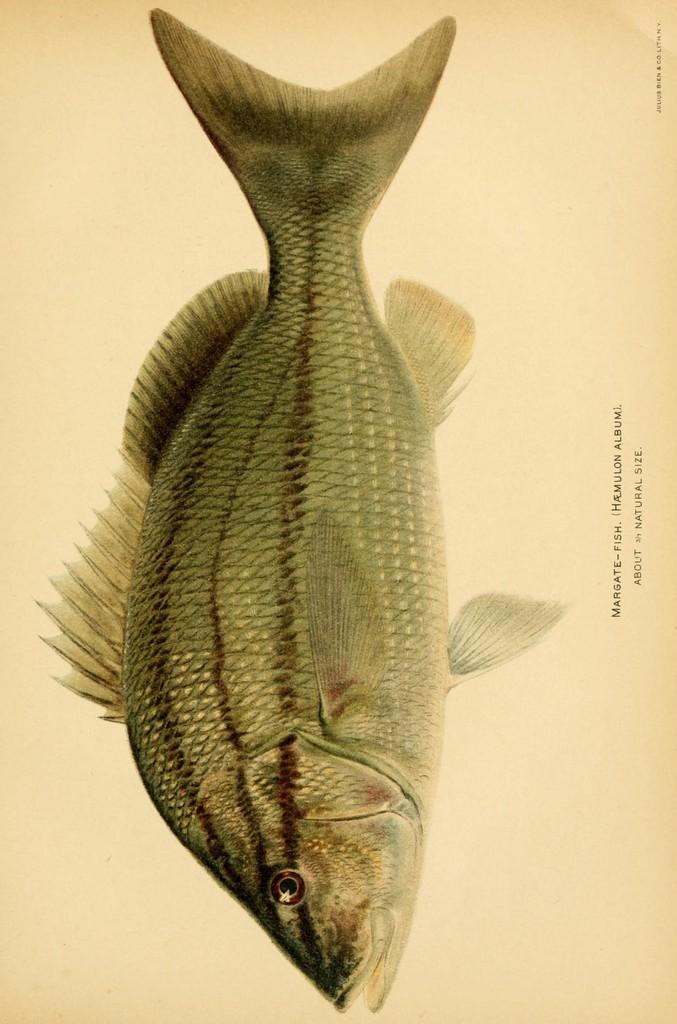What is depicted on the paper in the image? There is a drawing of a fish on the paper. Is there any text on the paper? Yes, there is writing on the paper. Are there any cobwebs visible on the paper in the image? No, there are no cobwebs present on the paper in the image. What type of writing is on the paper, prose or poetry? The type of writing on the paper cannot be determined from the image alone, as it only shows the presence of writing without any context or content. 